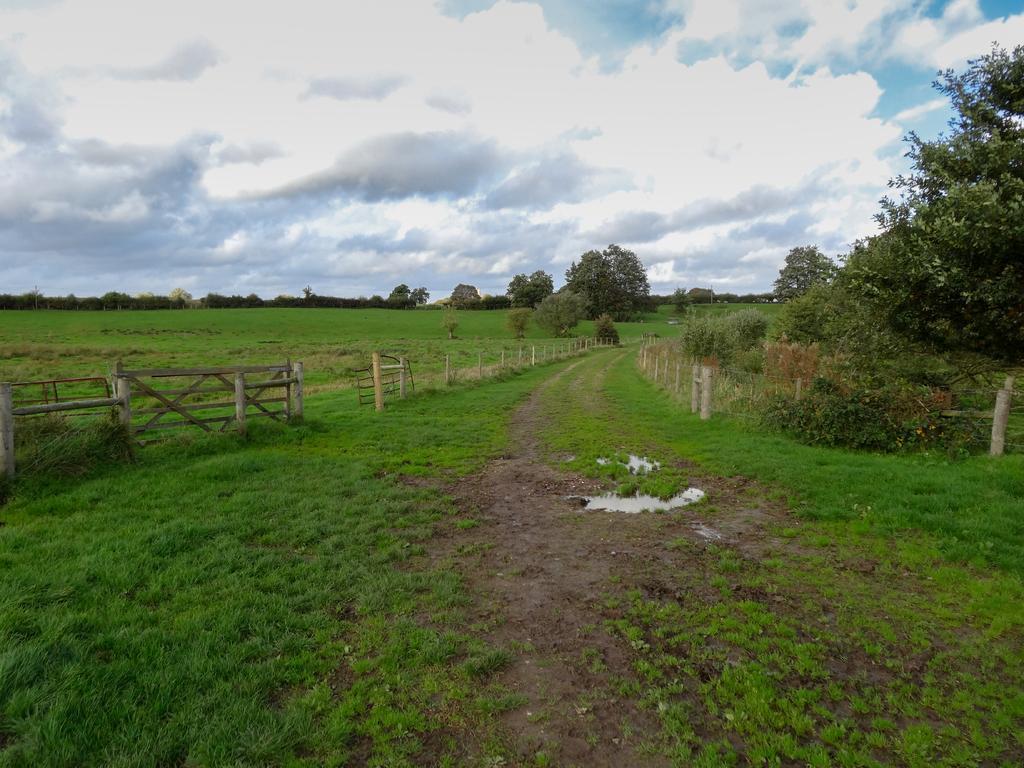How would you summarize this image in a sentence or two? There is a grassy land at the bottom of this image, and there is a fencing in the middle of this image. There are some trees in the background, and there is a cloudy sky at the top of this image. 